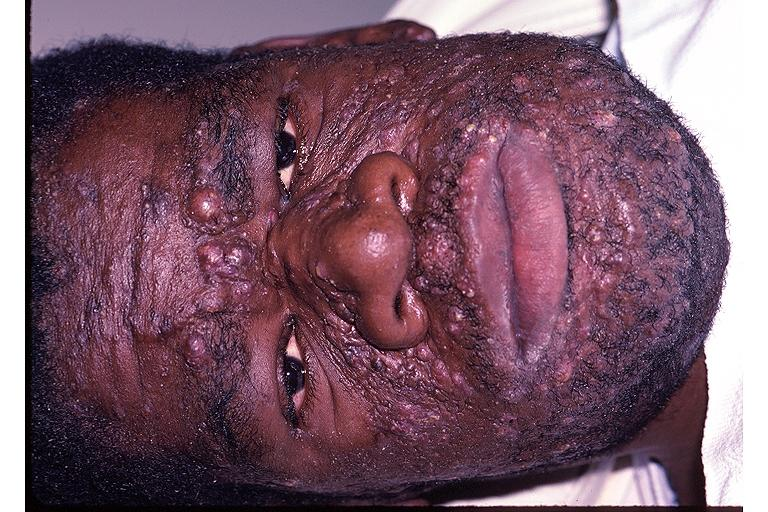what does this image show?
Answer the question using a single word or phrase. Neurofibromatosis 